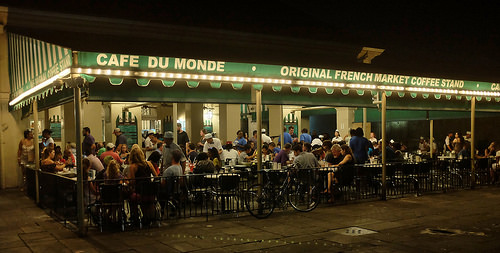<image>
Is there a man behind the man? No. The man is not behind the man. From this viewpoint, the man appears to be positioned elsewhere in the scene. 